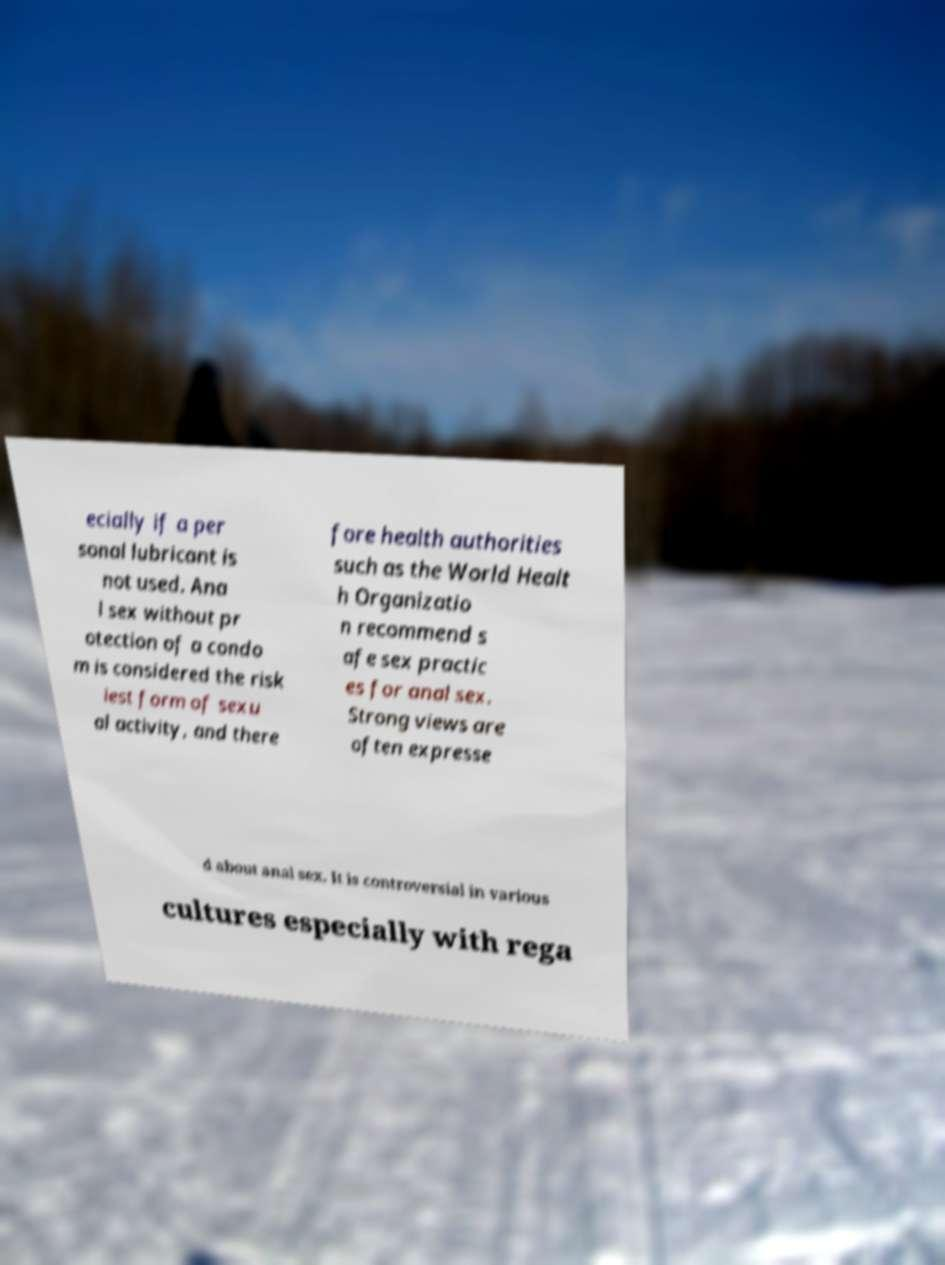Can you read and provide the text displayed in the image?This photo seems to have some interesting text. Can you extract and type it out for me? ecially if a per sonal lubricant is not used. Ana l sex without pr otection of a condo m is considered the risk iest form of sexu al activity, and there fore health authorities such as the World Healt h Organizatio n recommend s afe sex practic es for anal sex. Strong views are often expresse d about anal sex. It is controversial in various cultures especially with rega 